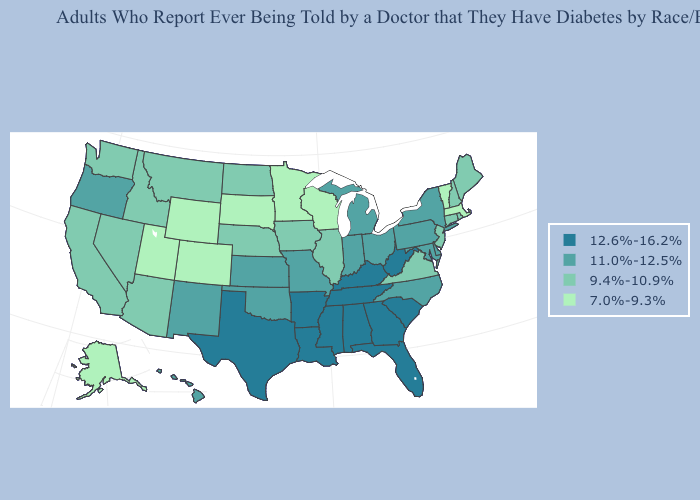Does the map have missing data?
Keep it brief. No. What is the value of Minnesota?
Give a very brief answer. 7.0%-9.3%. Does the first symbol in the legend represent the smallest category?
Quick response, please. No. Which states have the lowest value in the USA?
Quick response, please. Alaska, Colorado, Massachusetts, Minnesota, South Dakota, Utah, Vermont, Wisconsin, Wyoming. Among the states that border Delaware , which have the lowest value?
Concise answer only. New Jersey. What is the lowest value in the MidWest?
Keep it brief. 7.0%-9.3%. Does Kentucky have the lowest value in the USA?
Give a very brief answer. No. Does South Dakota have a lower value than Massachusetts?
Answer briefly. No. Name the states that have a value in the range 7.0%-9.3%?
Keep it brief. Alaska, Colorado, Massachusetts, Minnesota, South Dakota, Utah, Vermont, Wisconsin, Wyoming. What is the value of Rhode Island?
Be succinct. 9.4%-10.9%. What is the value of Hawaii?
Short answer required. 11.0%-12.5%. Does New Mexico have a lower value than Tennessee?
Write a very short answer. Yes. Does New Hampshire have the highest value in the USA?
Give a very brief answer. No. What is the lowest value in the USA?
Give a very brief answer. 7.0%-9.3%. 